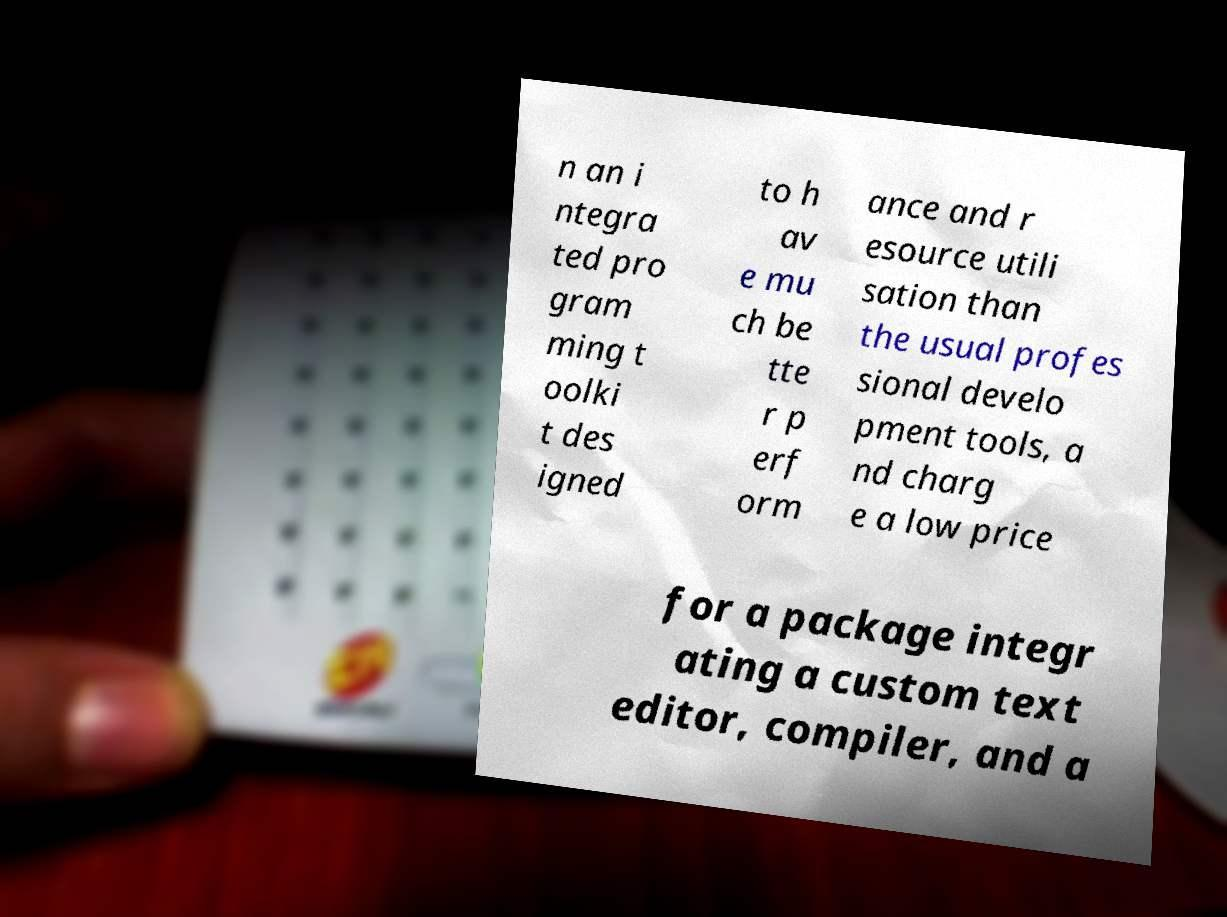Please identify and transcribe the text found in this image. n an i ntegra ted pro gram ming t oolki t des igned to h av e mu ch be tte r p erf orm ance and r esource utili sation than the usual profes sional develo pment tools, a nd charg e a low price for a package integr ating a custom text editor, compiler, and a 